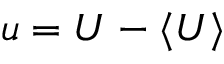Convert formula to latex. <formula><loc_0><loc_0><loc_500><loc_500>u = U - \langle U \rangle</formula> 